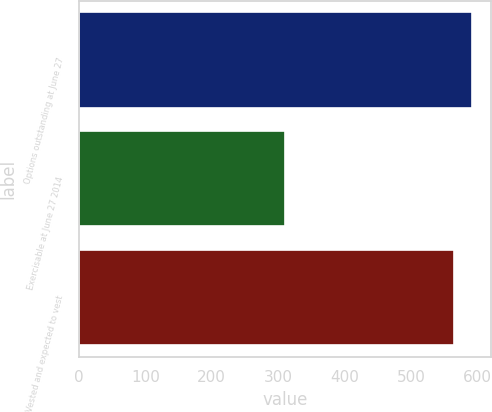<chart> <loc_0><loc_0><loc_500><loc_500><bar_chart><fcel>Options outstanding at June 27<fcel>Exercisable at June 27 2014<fcel>Vested and expected to vest<nl><fcel>591.2<fcel>310<fcel>565<nl></chart> 